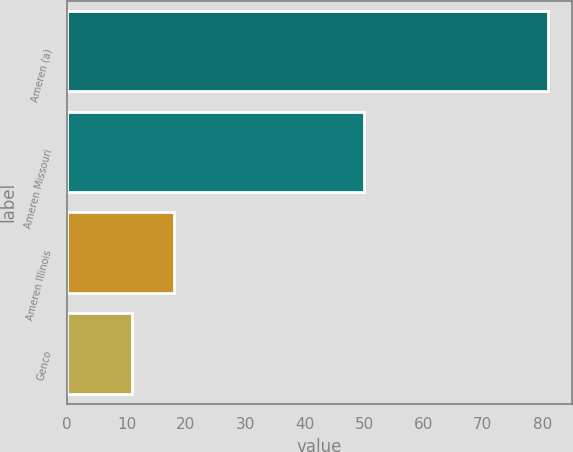Convert chart. <chart><loc_0><loc_0><loc_500><loc_500><bar_chart><fcel>Ameren (a)<fcel>Ameren Missouri<fcel>Ameren Illinois<fcel>Genco<nl><fcel>81<fcel>50<fcel>18<fcel>11<nl></chart> 